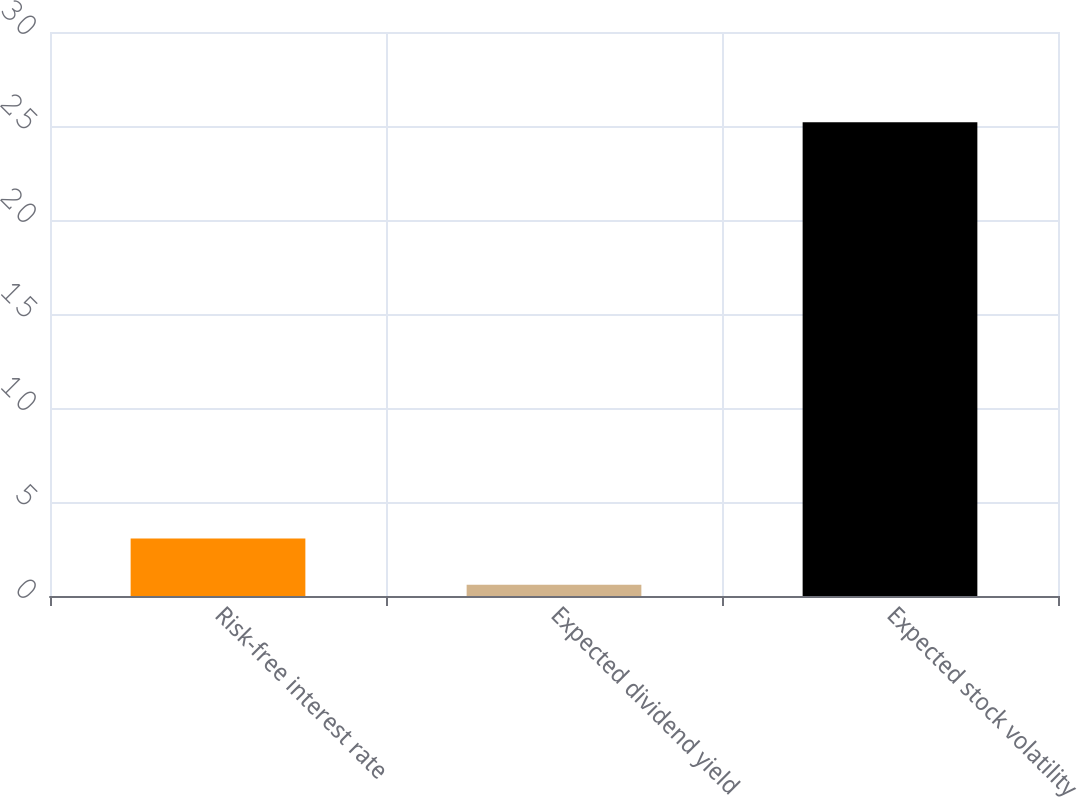<chart> <loc_0><loc_0><loc_500><loc_500><bar_chart><fcel>Risk-free interest rate<fcel>Expected dividend yield<fcel>Expected stock volatility<nl><fcel>3.06<fcel>0.6<fcel>25.2<nl></chart> 